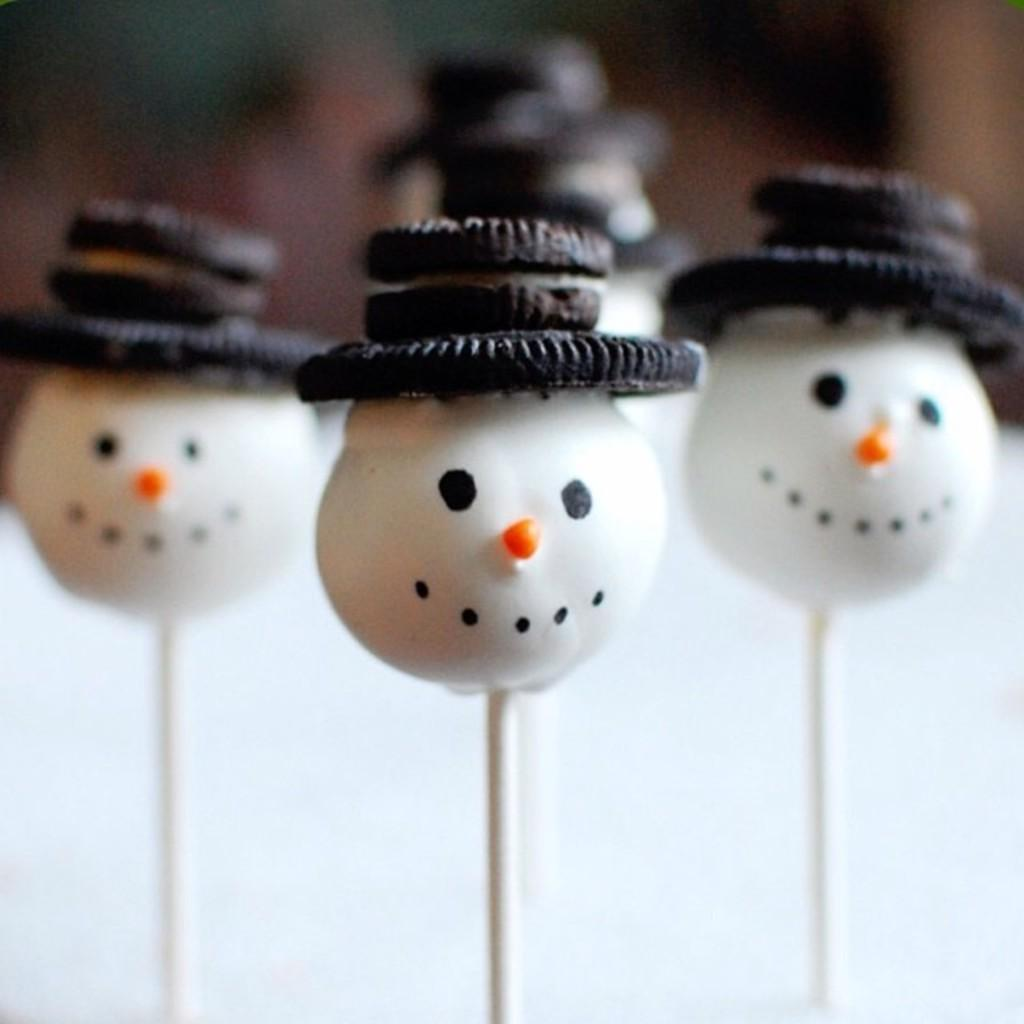What type of candy is present in the image? There are lollipops in the image. Can you tell me how deep the lake is in the image? There is no lake present in the image; it features lollipops. What type of paper is visible in the image? There is no paper present in the image; it features lollipops. 